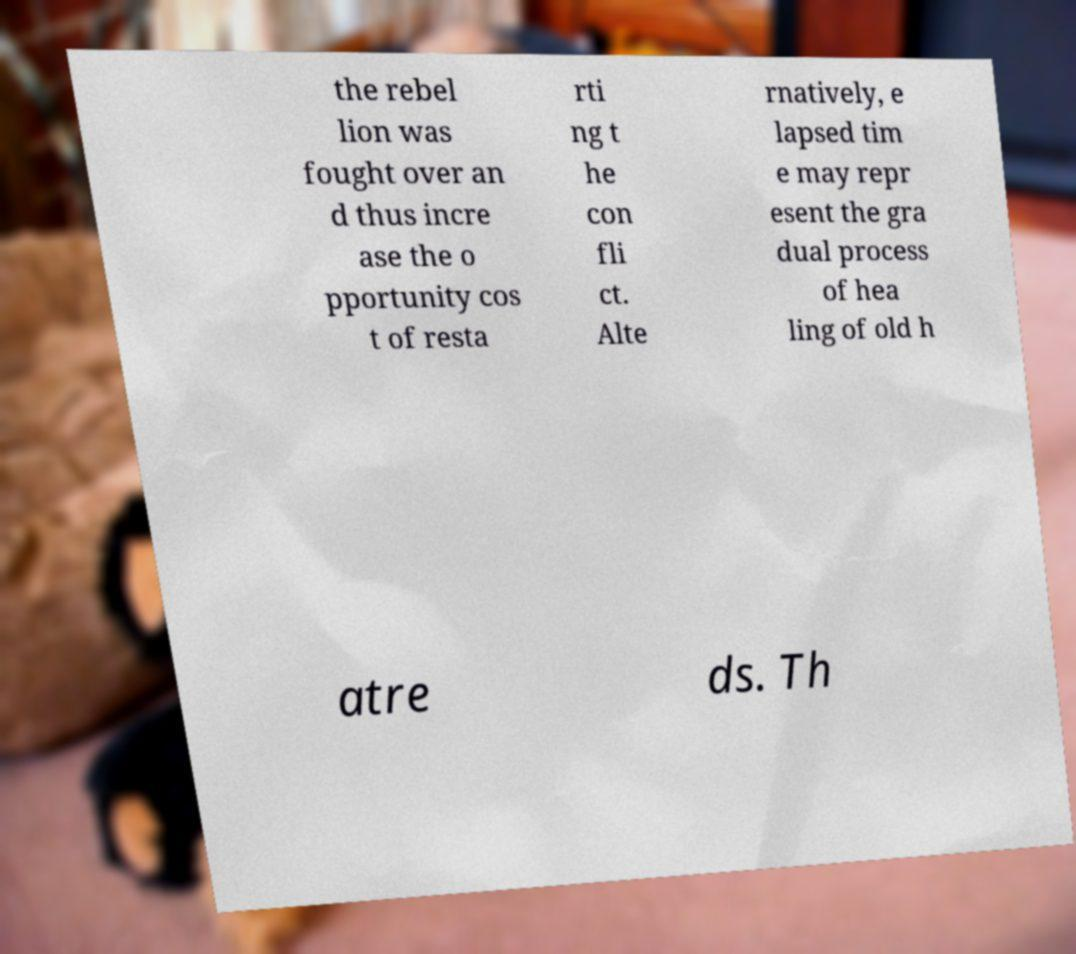Could you extract and type out the text from this image? the rebel lion was fought over an d thus incre ase the o pportunity cos t of resta rti ng t he con fli ct. Alte rnatively, e lapsed tim e may repr esent the gra dual process of hea ling of old h atre ds. Th 